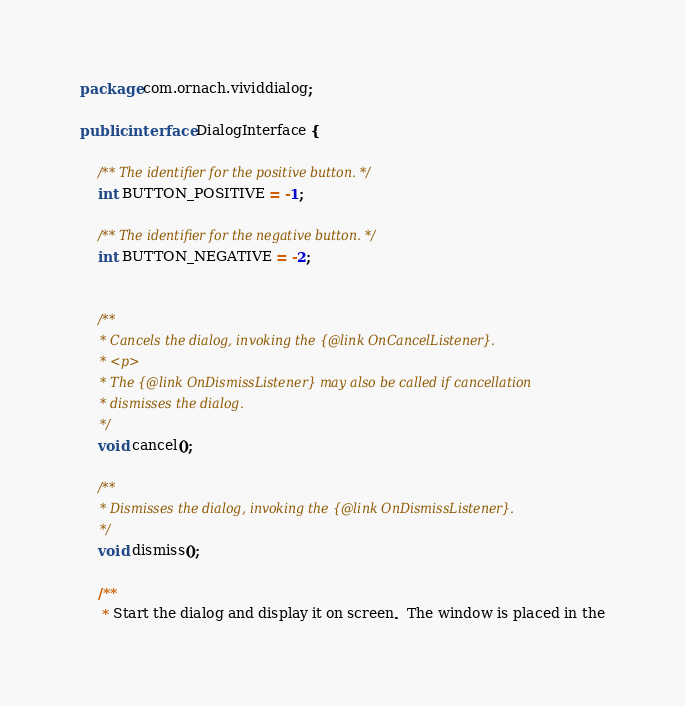Convert code to text. <code><loc_0><loc_0><loc_500><loc_500><_Java_>package com.ornach.vividdialog;

public interface DialogInterface {

    /** The identifier for the positive button. */
    int BUTTON_POSITIVE = -1;

    /** The identifier for the negative button. */
    int BUTTON_NEGATIVE = -2;


    /**
     * Cancels the dialog, invoking the {@link OnCancelListener}.
     * <p>
     * The {@link OnDismissListener} may also be called if cancellation
     * dismisses the dialog.
     */
    void cancel();

    /**
     * Dismisses the dialog, invoking the {@link OnDismissListener}.
     */
    void dismiss();

    /**
     * Start the dialog and display it on screen.  The window is placed in the</code> 